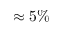<formula> <loc_0><loc_0><loc_500><loc_500>\approx 5 \%</formula> 